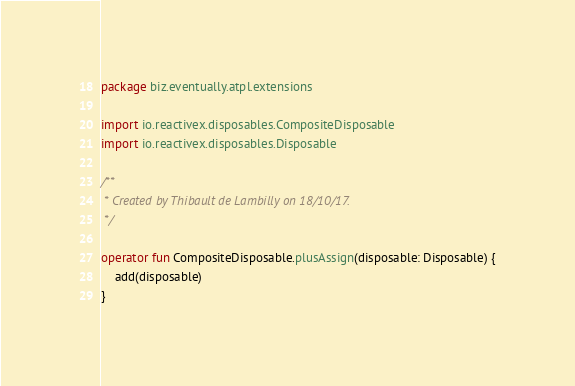<code> <loc_0><loc_0><loc_500><loc_500><_Kotlin_>package biz.eventually.atpl.extensions

import io.reactivex.disposables.CompositeDisposable
import io.reactivex.disposables.Disposable

/**
 * Created by Thibault de Lambilly on 18/10/17.
 */

operator fun CompositeDisposable.plusAssign(disposable: Disposable) {
    add(disposable)
}</code> 